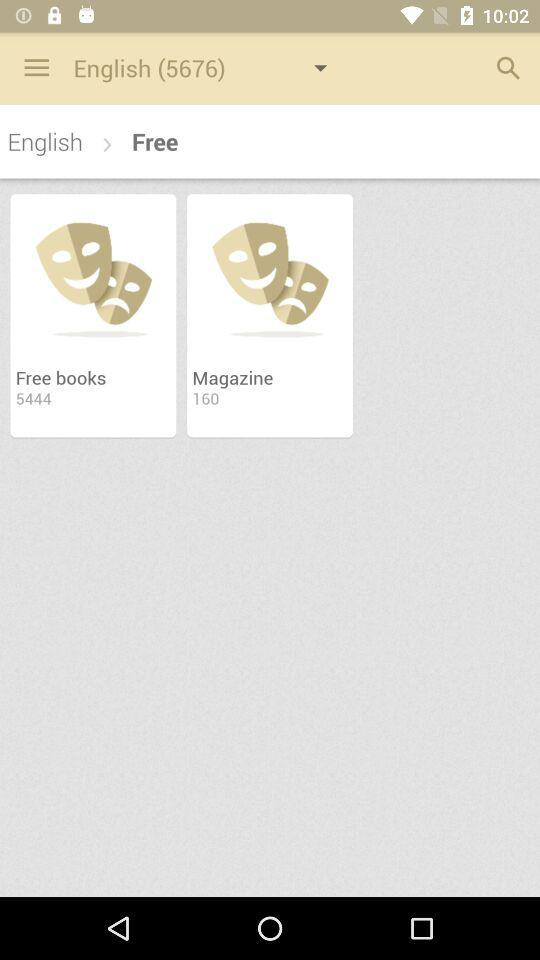What is the number for English in brackets? The number in brackets for English is 5676. 